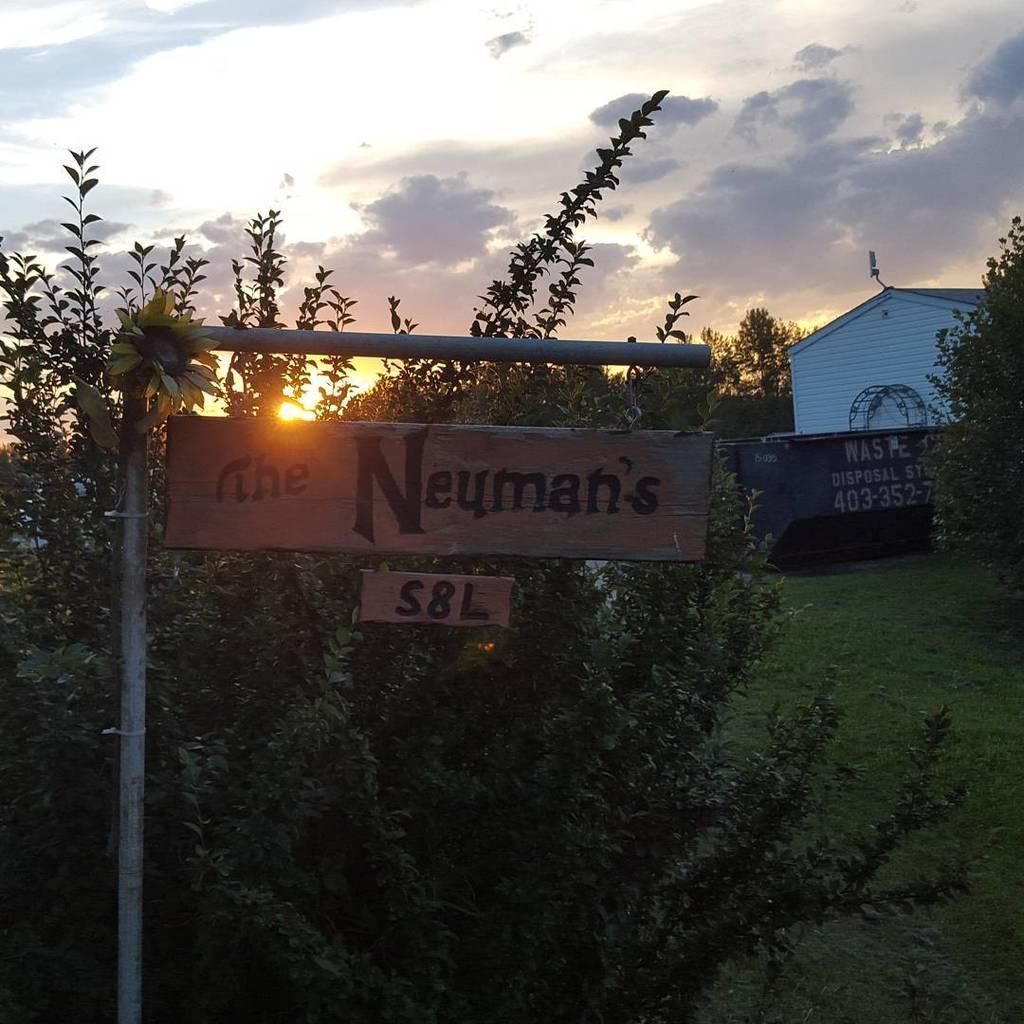Please provide a concise description of this image. In this picture I can see the signboard which is hanging from the pole. Beside that I can see the plants. On the right I can see the shed and brick wall. In the background I can see many trees. At the top I can see the sky, sun and clouds. In the right I can see the green grass. 